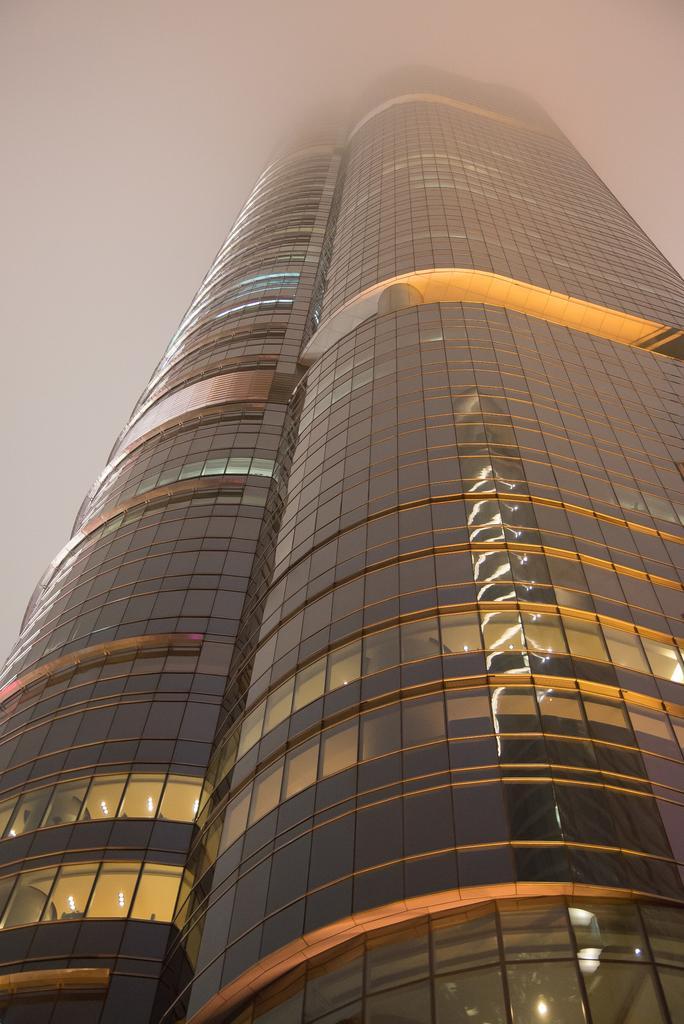Please provide a concise description of this image. This picture is clicked outside. In the center there is a skyscraper. In the background there is a sky. 